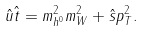<formula> <loc_0><loc_0><loc_500><loc_500>\hat { u } \hat { t } = m _ { h ^ { 0 } } ^ { 2 } m _ { W } ^ { 2 } + \hat { s } p _ { T } ^ { 2 } .</formula> 